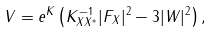Convert formula to latex. <formula><loc_0><loc_0><loc_500><loc_500>V = e ^ { K } \left ( K ^ { - 1 } _ { X X ^ { * } } | F _ { X } | ^ { 2 } - 3 | W | ^ { 2 } \right ) ,</formula> 